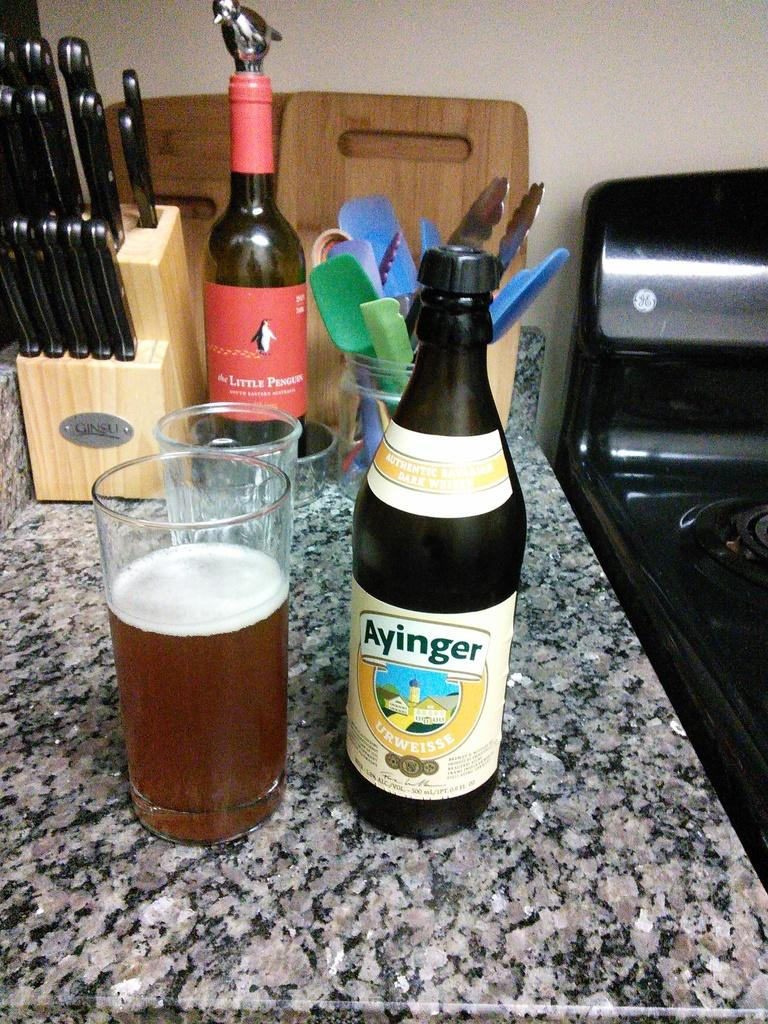<image>
Describe the image concisely. A bottle of Ayinger sits near a glass on a counter. 